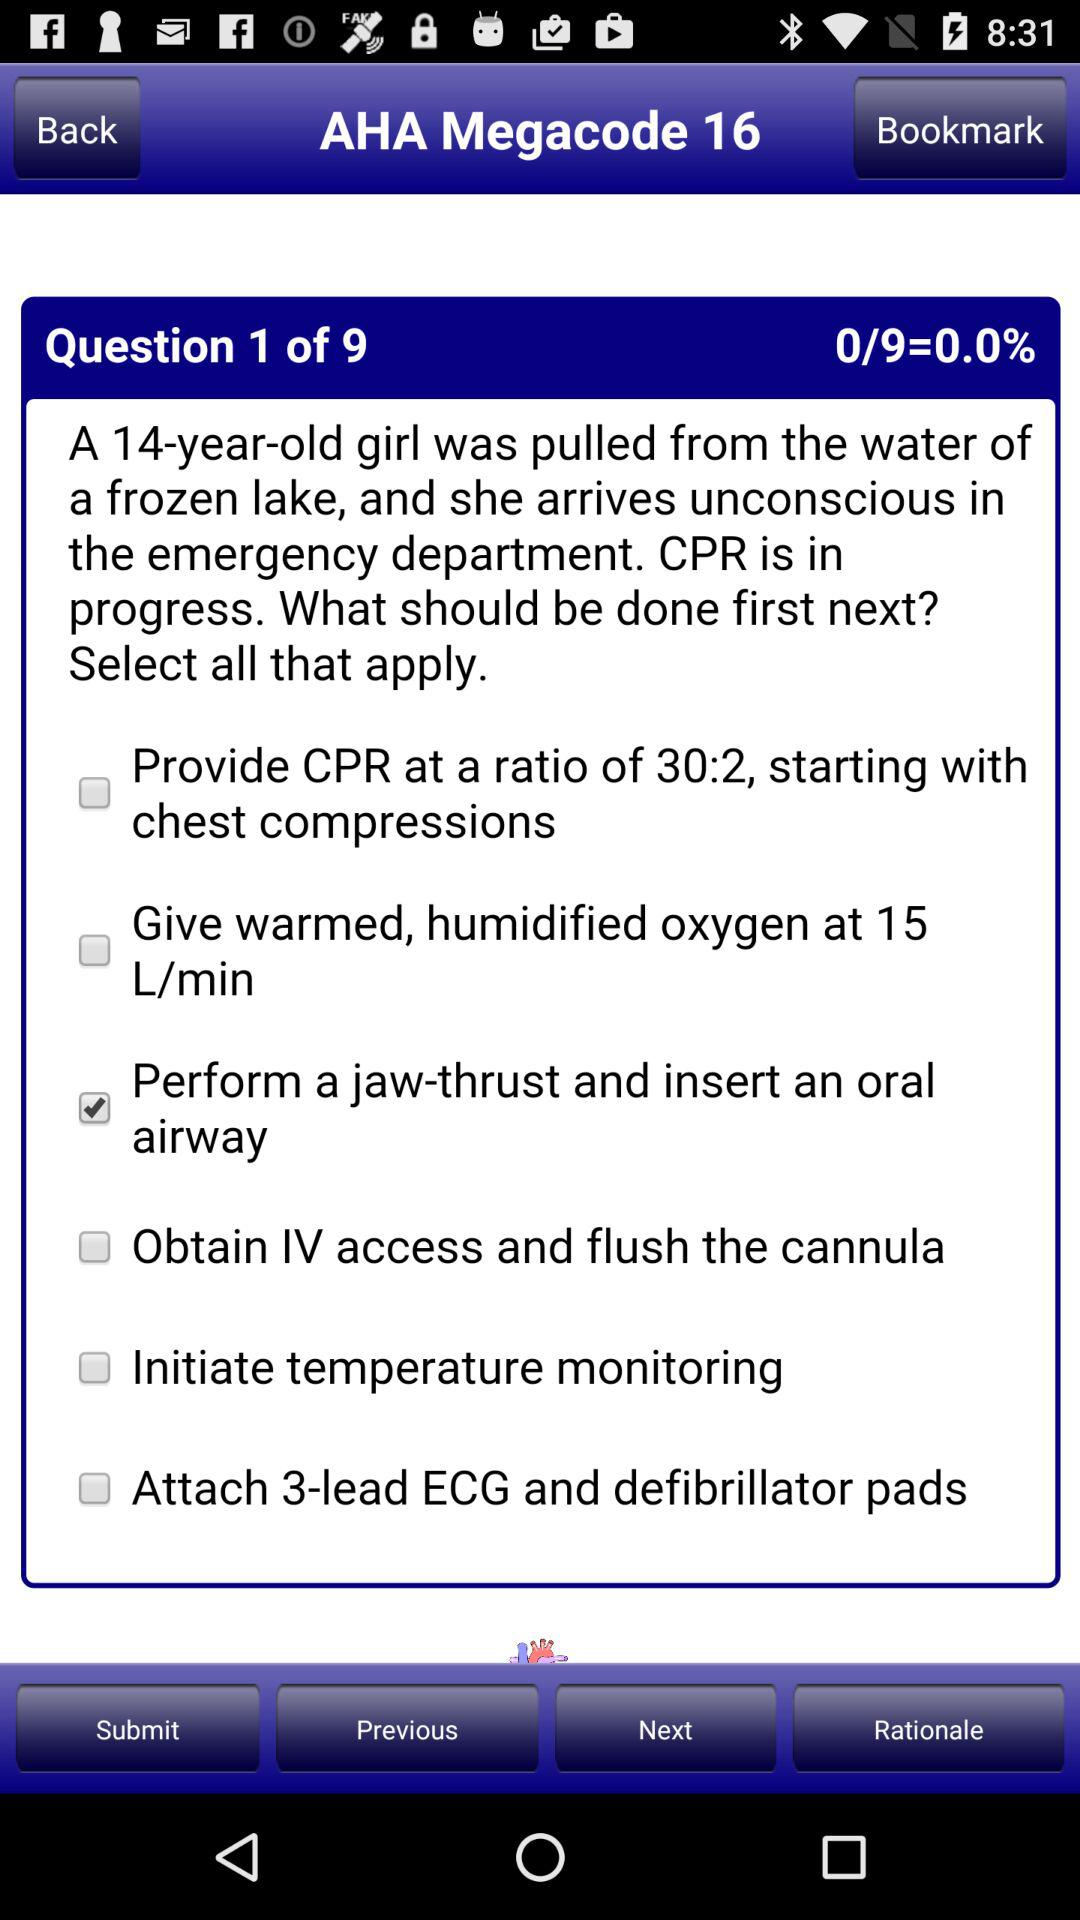What percentage is shown? The shown percentage is 0. 